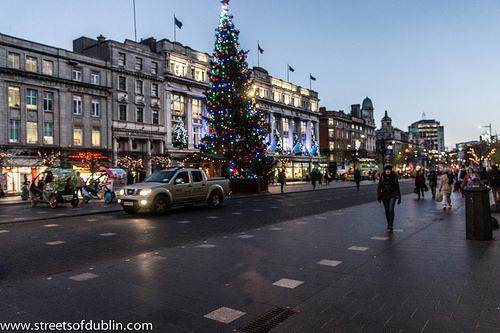<image>
Is the road to the right of the building? Yes. From this viewpoint, the road is positioned to the right side relative to the building. 